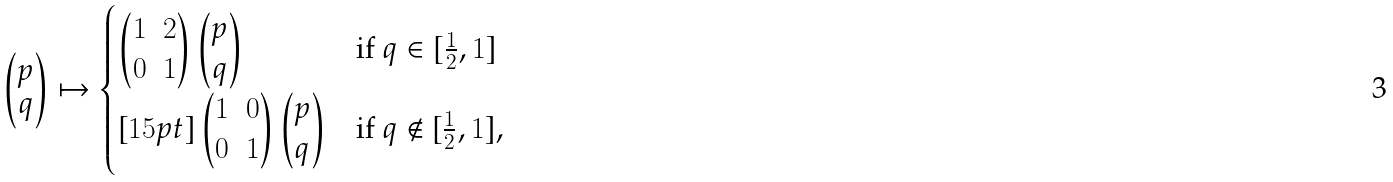<formula> <loc_0><loc_0><loc_500><loc_500>\begin{pmatrix} p \\ q \end{pmatrix} \mapsto \begin{cases} \begin{pmatrix} 1 & 2 \\ 0 & 1 \end{pmatrix} \begin{pmatrix} p \\ q \end{pmatrix} & \text {if } q \in [ \frac { 1 } { 2 } , 1 ] \\ [ 1 5 p t ] \begin{pmatrix} 1 & 0 \\ 0 & 1 \end{pmatrix} \begin{pmatrix} p \\ q \end{pmatrix} & \text {if } q \not \in [ \frac { 1 } { 2 } , 1 ] , \end{cases}</formula> 